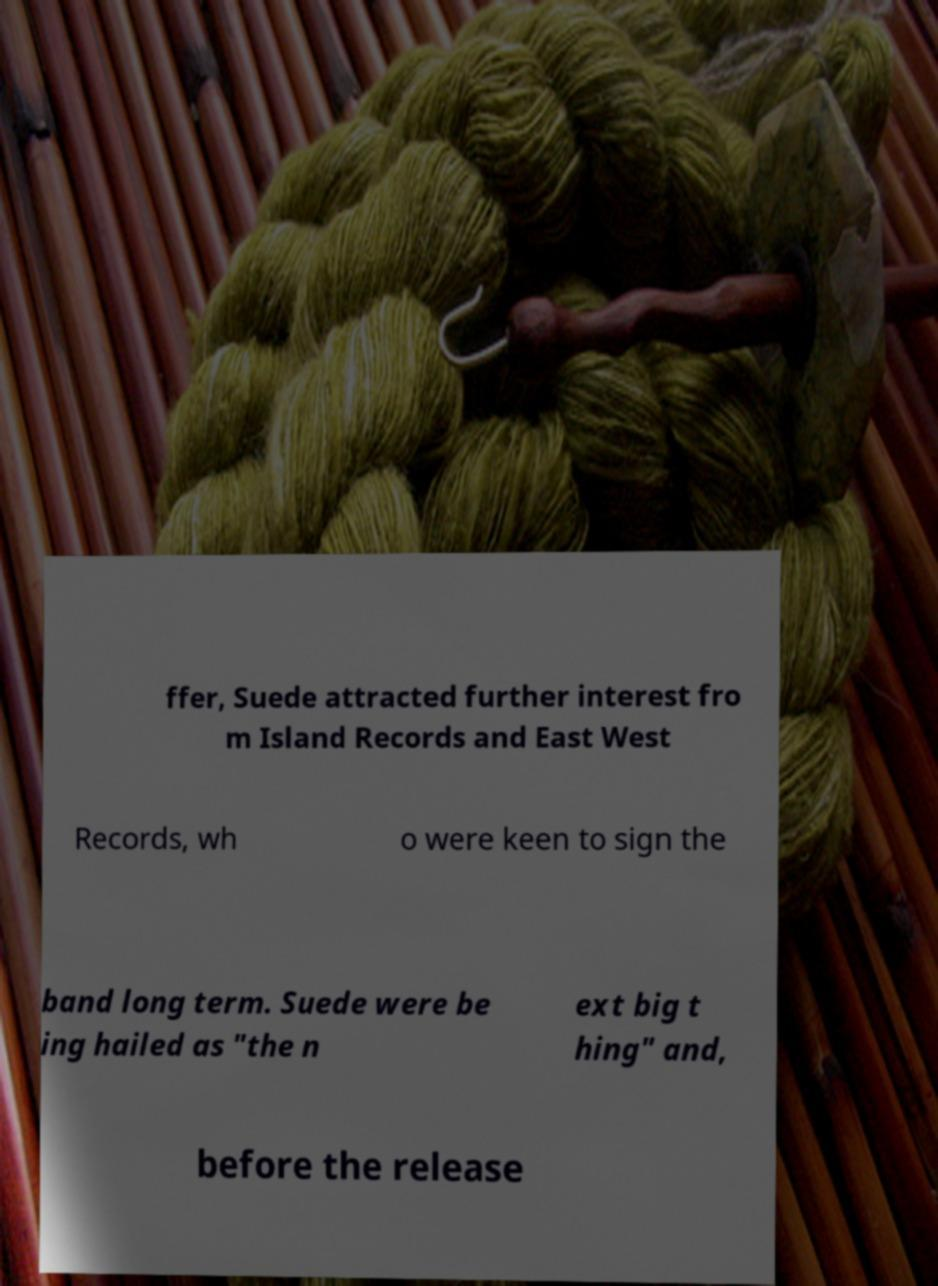Can you accurately transcribe the text from the provided image for me? ffer, Suede attracted further interest fro m Island Records and East West Records, wh o were keen to sign the band long term. Suede were be ing hailed as "the n ext big t hing" and, before the release 